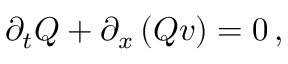<formula> <loc_0><loc_0><loc_500><loc_500>\partial _ { t } Q + \partial _ { x } \left ( Q v \right ) = 0 \, ,</formula> 